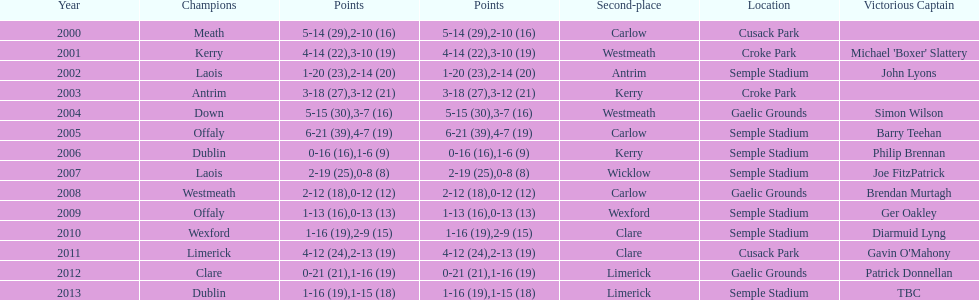What is the total number of times the competition was held at the semple stadium venue? 7. 